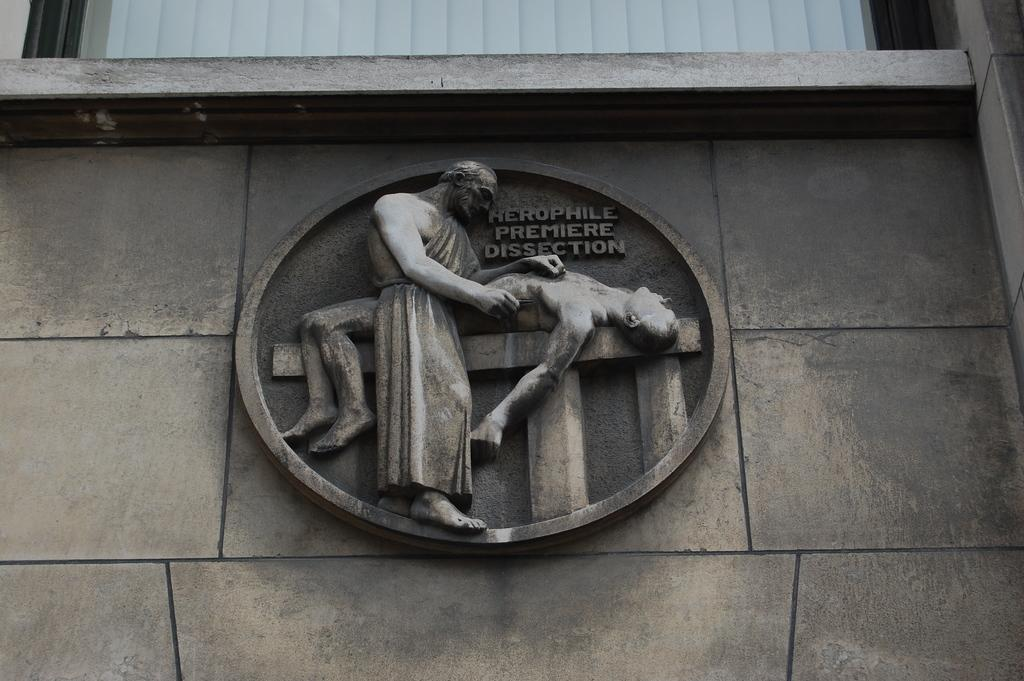What is the main structure in the center of the image? There is a building in the center of the image. What other architectural feature can be seen in the image? There is a wall in the image. What color is the prominent object in the image? There is a white color object in the image. What type of artwork is present in the image? There are sculptures in the image. Are there any other objects visible in the image? Yes, there are other objects in the image. What is written or depicted on the wall? There is text on the wall. What type of doll is sitting on the bean in the image? There is no doll or bean present in the image. 